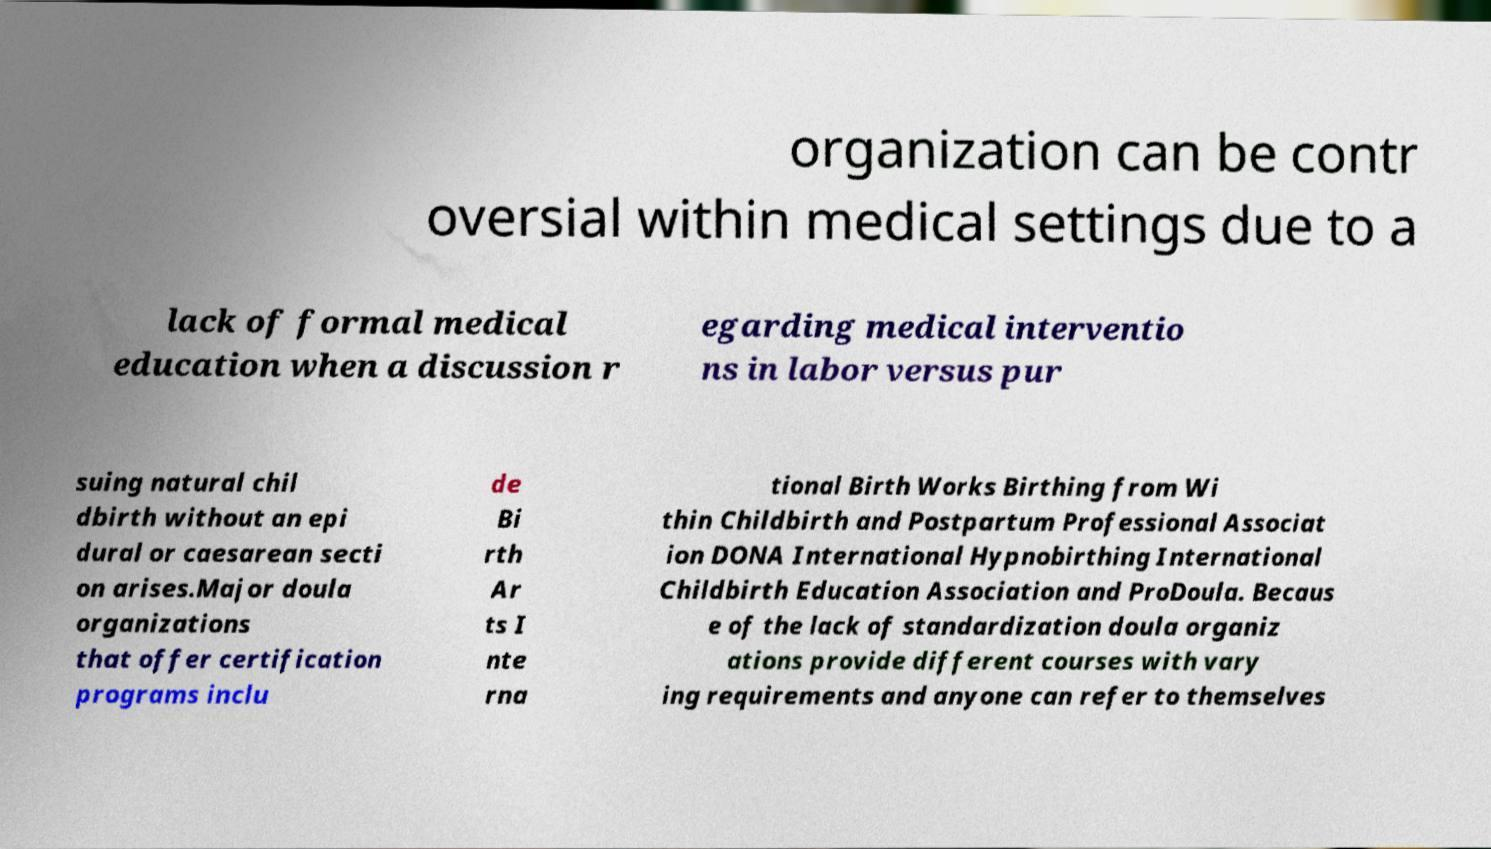Please read and relay the text visible in this image. What does it say? organization can be contr oversial within medical settings due to a lack of formal medical education when a discussion r egarding medical interventio ns in labor versus pur suing natural chil dbirth without an epi dural or caesarean secti on arises.Major doula organizations that offer certification programs inclu de Bi rth Ar ts I nte rna tional Birth Works Birthing from Wi thin Childbirth and Postpartum Professional Associat ion DONA International Hypnobirthing International Childbirth Education Association and ProDoula. Becaus e of the lack of standardization doula organiz ations provide different courses with vary ing requirements and anyone can refer to themselves 